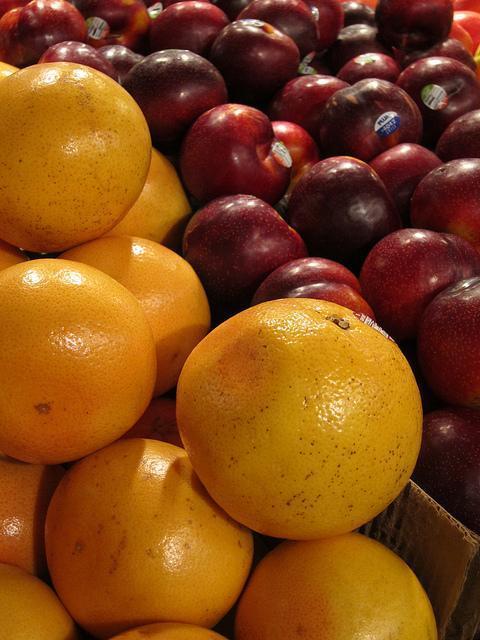How many cherries are there?
Give a very brief answer. 0. How many apples are there?
Give a very brief answer. 5. 